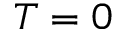<formula> <loc_0><loc_0><loc_500><loc_500>T = 0</formula> 